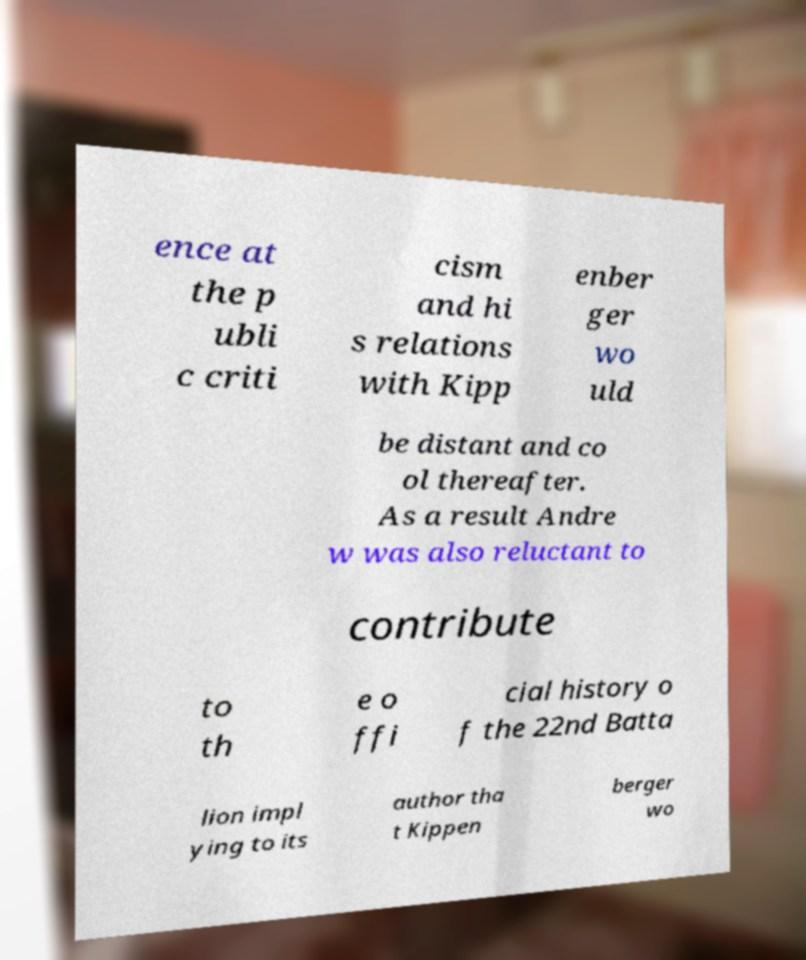Please identify and transcribe the text found in this image. ence at the p ubli c criti cism and hi s relations with Kipp enber ger wo uld be distant and co ol thereafter. As a result Andre w was also reluctant to contribute to th e o ffi cial history o f the 22nd Batta lion impl ying to its author tha t Kippen berger wo 